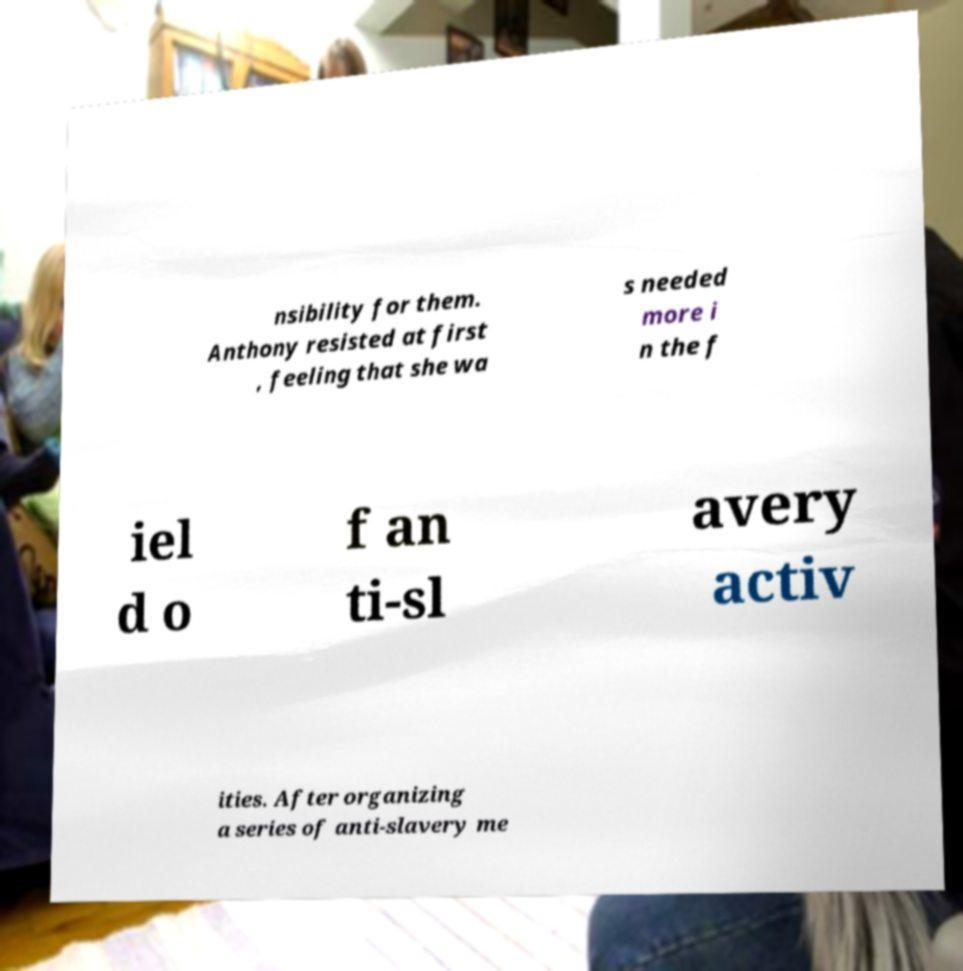There's text embedded in this image that I need extracted. Can you transcribe it verbatim? nsibility for them. Anthony resisted at first , feeling that she wa s needed more i n the f iel d o f an ti-sl avery activ ities. After organizing a series of anti-slavery me 